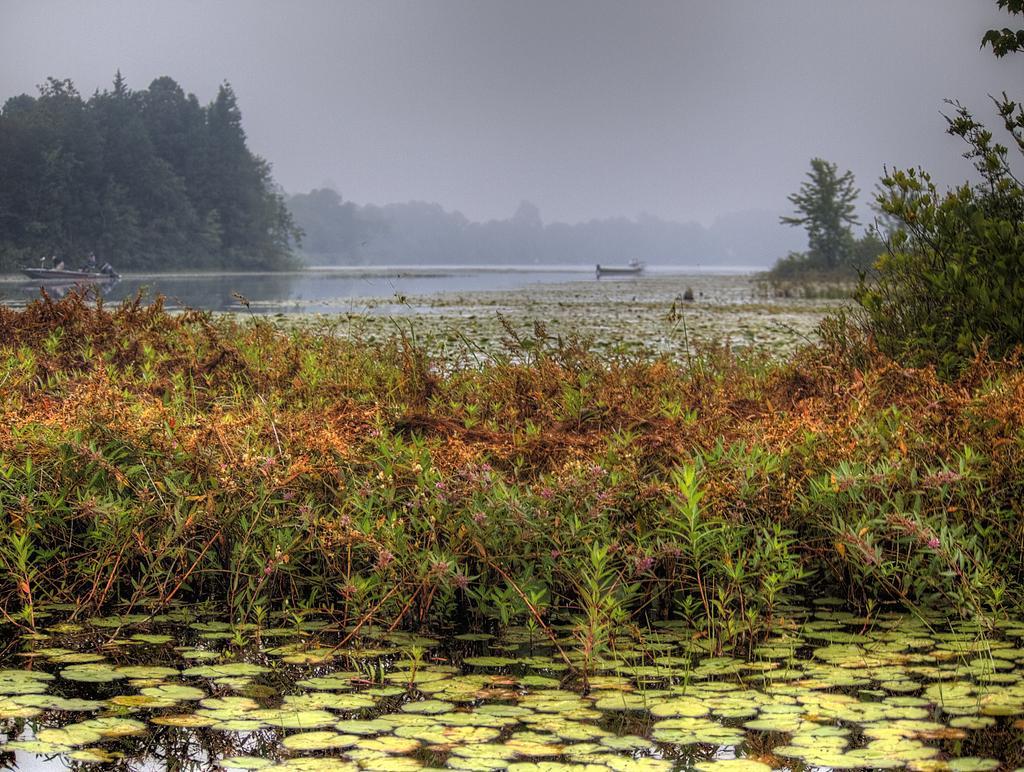Could you give a brief overview of what you see in this image? In this image at the bottom there is a river in the river there are some leaves, and in the center of the image there are some plants. And in the background there are boats, trees, and at the top there is sky. 